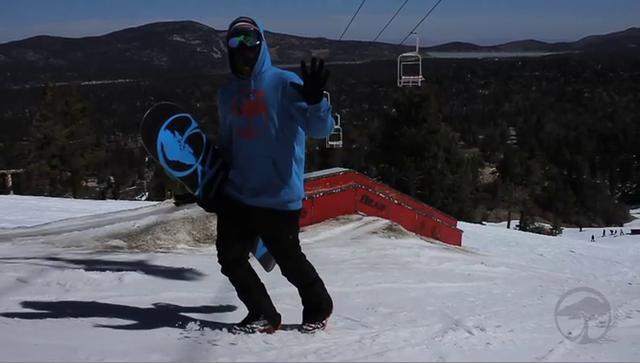Where is this taken place?
Quick response, please. Ski slope. What color is his sweatshirt?
Short answer required. Blue. What are the three black lines in the sky?
Concise answer only. Ski lift. 